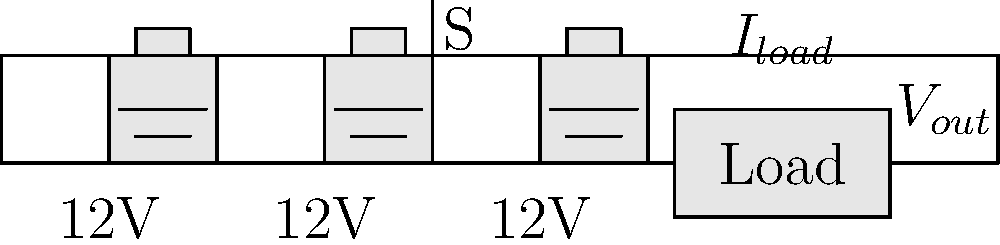In the backup power system shown above, three 12V batteries are connected in series to supply a load. The load requires 30V and draws 2A of current. If the switch S is closed, what is the maximum duration this system can supply power to the load if each battery has a capacity of 50Ah? To solve this problem, let's follow these steps:

1. Calculate the total voltage supplied by the batteries:
   $V_{total} = 12V + 12V + 12V = 36V$

2. Verify if the system meets the load voltage requirement:
   The load requires 30V, and the system supplies 36V, so it's sufficient.

3. Calculate the current drawn from the battery system:
   Since the batteries are in series, the current drawn from each battery is equal to the load current, which is 2A.

4. Determine the capacity of the battery system:
   The batteries are connected in series, so the total capacity remains 50Ah.

5. Calculate the maximum duration:
   Duration = Battery Capacity / Current Draw
   $T = \frac{50Ah}{2A} = 25h$

Therefore, the system can supply power to the load for a maximum of 25 hours.

Note: This calculation assumes ideal conditions and doesn't account for factors like battery efficiency, depth of discharge limitations, or voltage drop as the batteries discharge.
Answer: 25 hours 